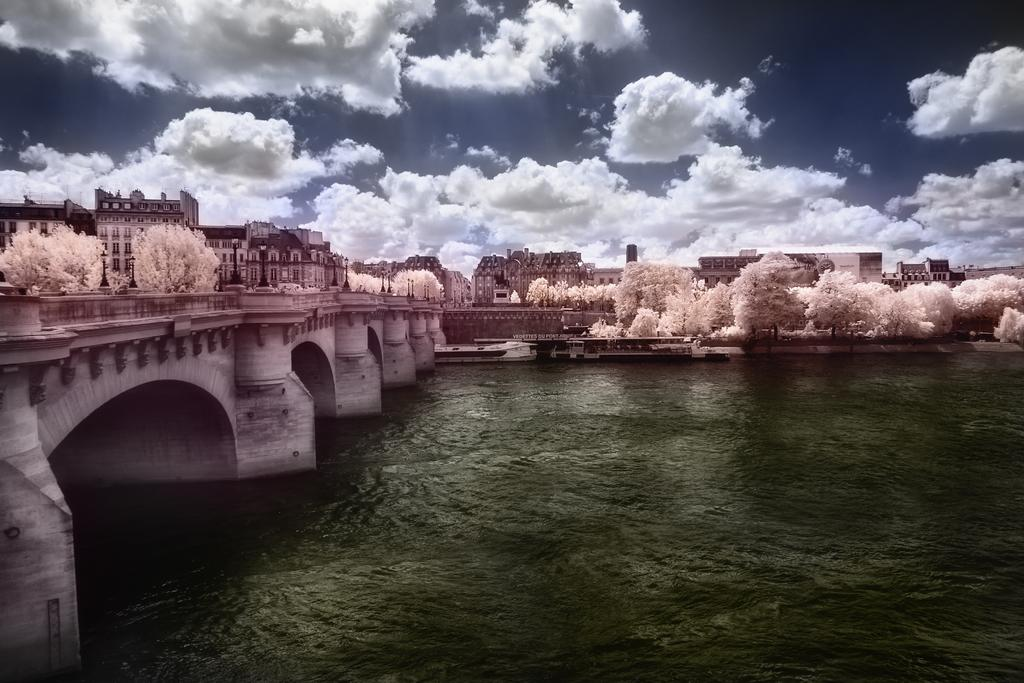What is the main structure in the image? There is a bridge in the image. What is the bridge positioned over? The bridge is over a river. What type of vehicle can be seen in the image? There is a ship in the image. What type of man-made structures are visible in the image? There are buildings in the image. What type of street furniture is present in the image? Street poles and street lights are visible in the image. What type of natural elements are present in the image? Trees and the sky are visible in the image. What is the condition of the sky in the image? Clouds are present in the sky. What type of jar is being used to catch the wave in the image? There is no jar or wave present in the image. 